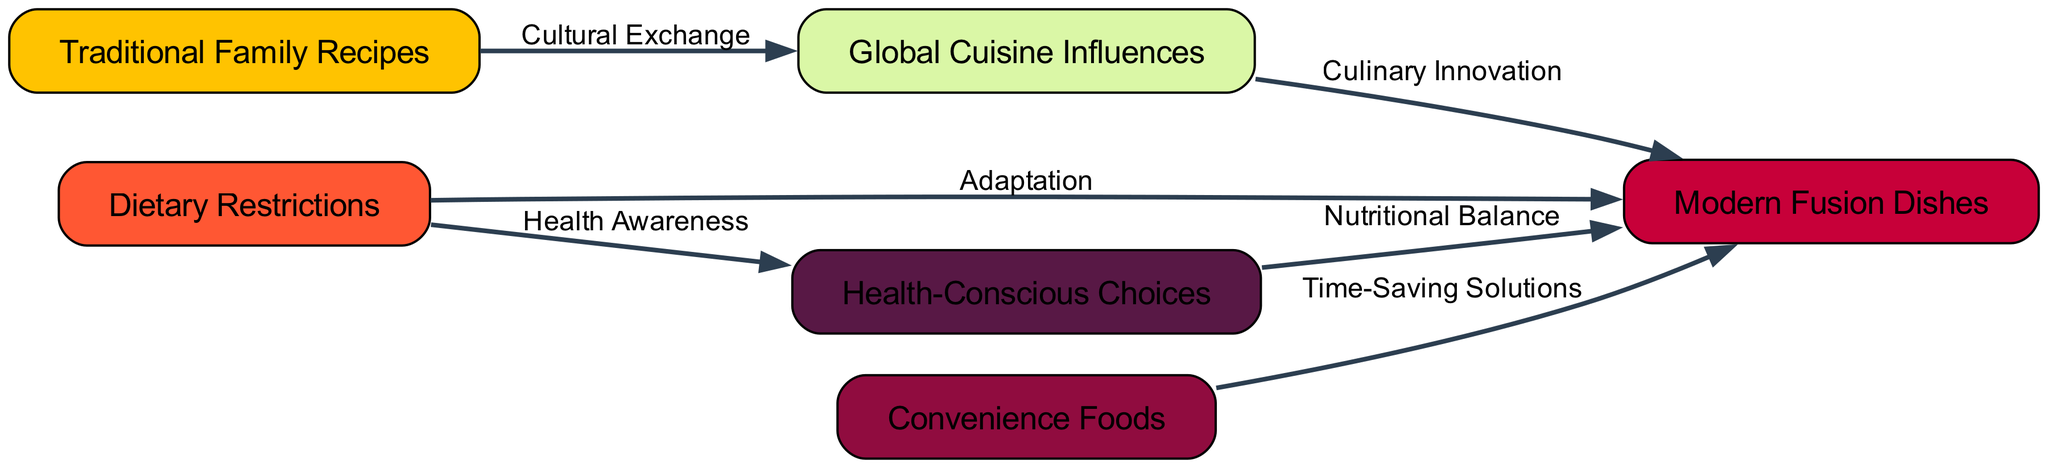What's the total number of nodes in the diagram? The diagram lists six distinct nodes representing various concepts related to family meal preferences: Traditional Family Recipes, Global Cuisine Influences, Dietary Restrictions, Modern Fusion Dishes, Convenience Foods, and Health-Conscious Choices. Counting these gives a total of 6 nodes.
Answer: 6 What is the relationship between Traditional Family Recipes and Global Cuisine Influences? The edge from Traditional Family Recipes to Global Cuisine Influences is labeled "Cultural Exchange," indicating that traditional recipes influence and contribute to global cuisine through the exchange of culinary practices.
Answer: Cultural Exchange Which node has the most incoming edges? By analyzing the diagram, both Modern Fusion Dishes and Health-Conscious Choices have incoming edges from multiple nodes. Modern Fusion Dishes receives edges from Global Cuisine Influences, Dietary Restrictions, and Convenience Foods, totaling three incoming edges. Thus, it has the most incoming edges.
Answer: Modern Fusion Dishes What does the edge labeled "Time-Saving Solutions" connect? The edge labeled "Time-Saving Solutions" connects Convenience Foods to Modern Fusion Dishes, showing that the convenience derived from ready-made foods can lead to the creation of modern fusion dishes in family meals.
Answer: Convenience Foods to Modern Fusion Dishes How many edges lead to the node Health-Conscious Choices? There are two edges directed towards the Health-Conscious Choices node, which come from Dietary Restrictions (labeled Health Awareness) and Modern Fusion Dishes (labeled Nutritional Balance).
Answer: 2 What influences the creation of Modern Fusion Dishes? Modern Fusion Dishes are influenced by Global Cuisine Influences through Culinary Innovation, Dietary Restrictions through Adaptation, Convenience Foods through Time-Saving Solutions, and Health-Conscious Choices through Nutritional Balance. Thus, there are multiple influences contributing to modern fusion dishes.
Answer: Global Cuisine Influences, Dietary Restrictions, Convenience Foods, Health-Conscious Choices Which node results from the combination of "Dietary Restrictions" and "Health-Conscious Choices"? Both Dietary Restrictions and Health-Conscious Choices contribute to the creation of Modern Fusion Dishes, with the goal of adapting meals to fit health requirements and preferences. Thus, these two nodes directly relate to the combination that results in modern fusion dishes.
Answer: Modern Fusion Dishes What kind of exchange is identified in the diagram? The diagram identifies "Cultural Exchange" as the exchange type occurring between Traditional Family Recipes and Global Cuisine Influences, emphasizing how family recipes can blend with international cooking styles through shared knowledge and practices.
Answer: Cultural Exchange 